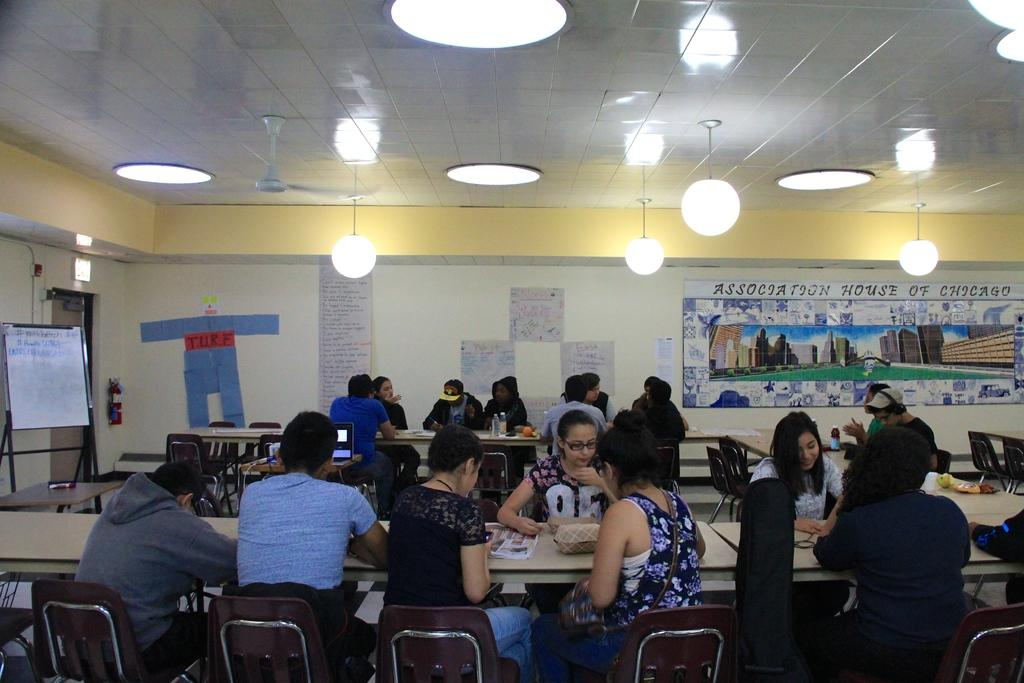What are the people in the image doing? The people in the image are sitting on chairs. What type of furniture is present in the image besides chairs? There are tables in the image. What can be seen on the walls in the image? There are boards and posters in the image. What safety equipment is visible in the image? There is a fire extinguisher in the image. What architectural features can be seen in the image? There is a wall, a door, and a ceiling in the image. What type of lighting is present in the image? There are lights in the image. Are there any other objects in the image besides the ones mentioned? Yes, there are other objects in the image. What type of grape is being used as a paperweight on the table in the image? There is no grape present in the image, let alone being used as a paperweight. 